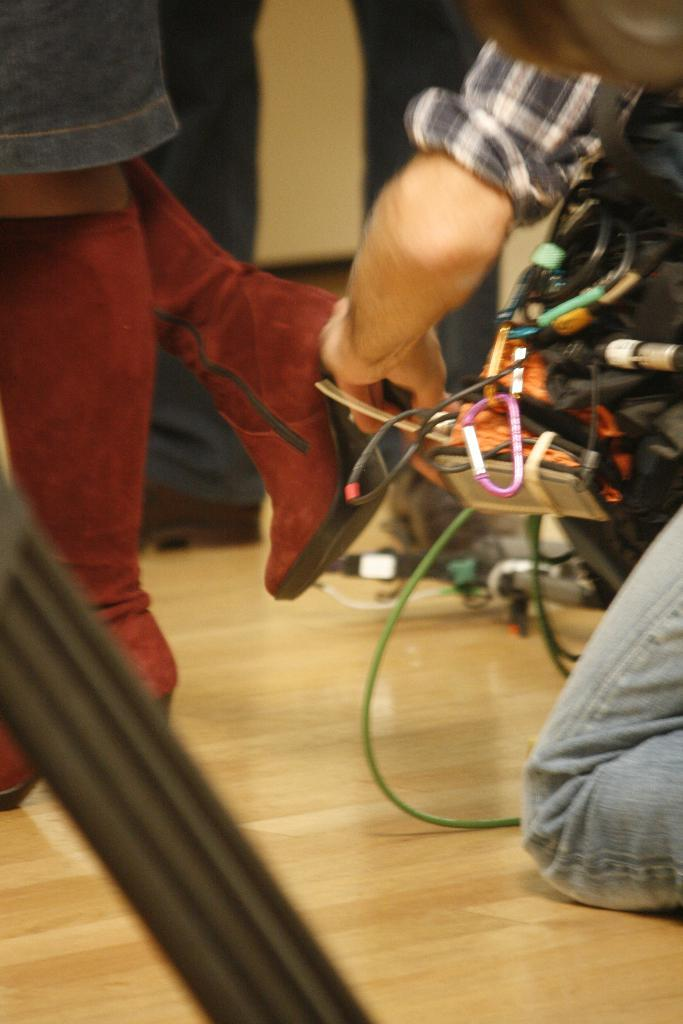What is the person in the image holding? The person in the image is holding wires. Can you describe the person's clothing? The person is wearing a check shirt and blue jeans. Where is the person positioned in the image? The person is positioned towards the right side of the right side of the image. Are there any other people visible in the image? Yes, there is another person whose legs are visible in the image, and they are positioned towards the left side. What type of destruction can be seen in the image? There is no destruction visible in the image; it features a person holding wires and another person whose legs are visible. What type of liquid is being used by the person in the image? There is no liquid visible in the image; the person is holding wires. 